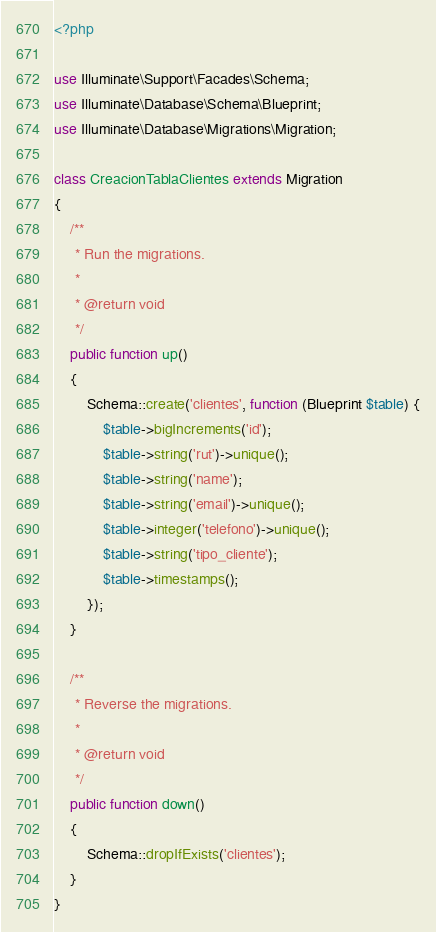Convert code to text. <code><loc_0><loc_0><loc_500><loc_500><_PHP_><?php

use Illuminate\Support\Facades\Schema;
use Illuminate\Database\Schema\Blueprint;
use Illuminate\Database\Migrations\Migration;

class CreacionTablaClientes extends Migration
{
    /**
     * Run the migrations.
     *
     * @return void
     */
    public function up()
    {
        Schema::create('clientes', function (Blueprint $table) {
            $table->bigIncrements('id');
            $table->string('rut')->unique();
            $table->string('name');
            $table->string('email')->unique();
            $table->integer('telefono')->unique();
            $table->string('tipo_cliente');
            $table->timestamps();
        });
    }

    /**
     * Reverse the migrations.
     *
     * @return void
     */
    public function down()
    {
        Schema::dropIfExists('clientes');
    }
}
</code> 